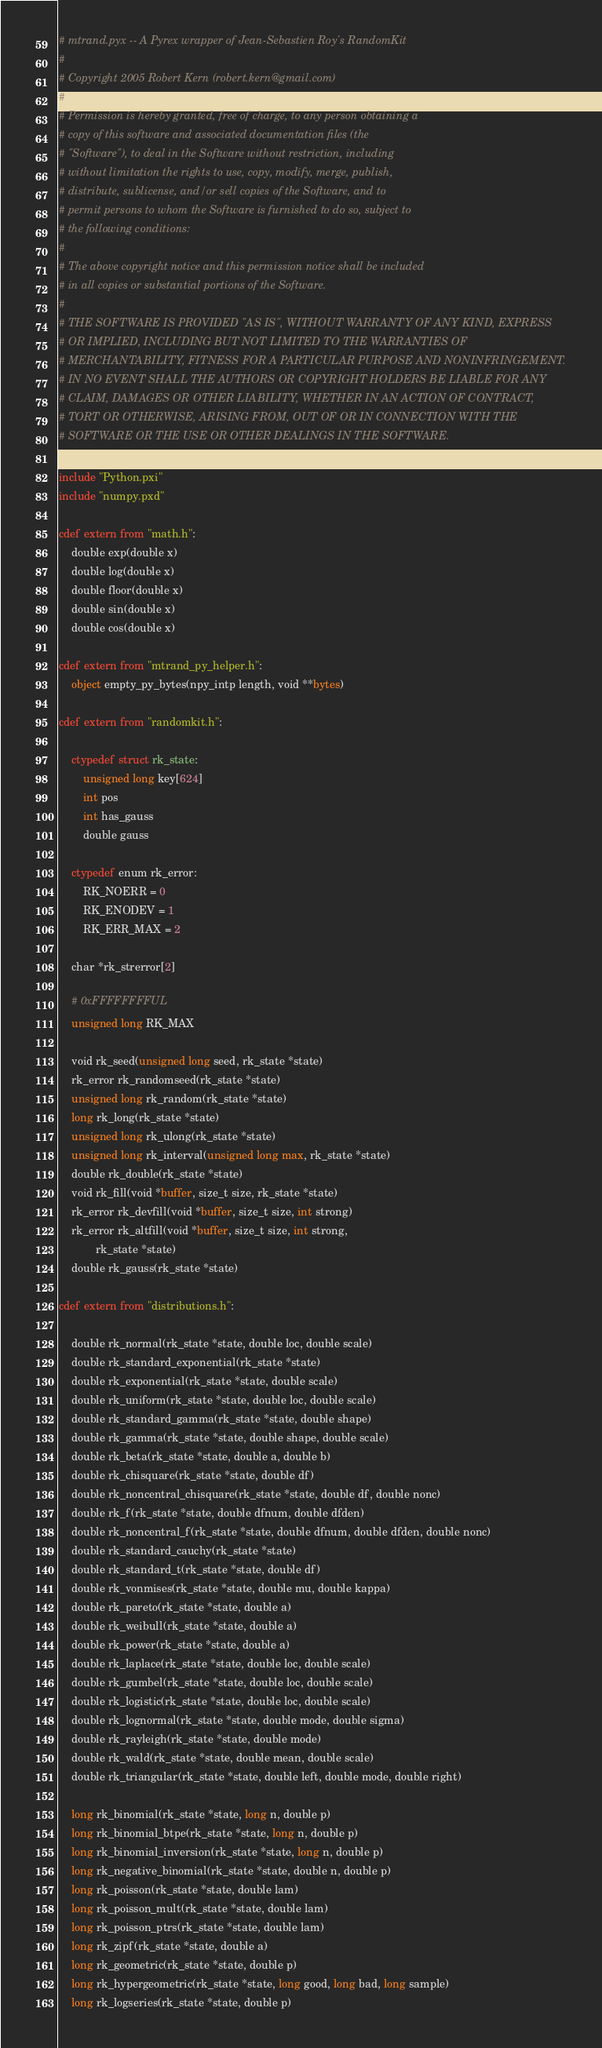Convert code to text. <code><loc_0><loc_0><loc_500><loc_500><_Cython_># mtrand.pyx -- A Pyrex wrapper of Jean-Sebastien Roy's RandomKit
#
# Copyright 2005 Robert Kern (robert.kern@gmail.com)
#
# Permission is hereby granted, free of charge, to any person obtaining a
# copy of this software and associated documentation files (the
# "Software"), to deal in the Software without restriction, including
# without limitation the rights to use, copy, modify, merge, publish,
# distribute, sublicense, and/or sell copies of the Software, and to
# permit persons to whom the Software is furnished to do so, subject to
# the following conditions:
#
# The above copyright notice and this permission notice shall be included
# in all copies or substantial portions of the Software.
#
# THE SOFTWARE IS PROVIDED "AS IS", WITHOUT WARRANTY OF ANY KIND, EXPRESS
# OR IMPLIED, INCLUDING BUT NOT LIMITED TO THE WARRANTIES OF
# MERCHANTABILITY, FITNESS FOR A PARTICULAR PURPOSE AND NONINFRINGEMENT.
# IN NO EVENT SHALL THE AUTHORS OR COPYRIGHT HOLDERS BE LIABLE FOR ANY
# CLAIM, DAMAGES OR OTHER LIABILITY, WHETHER IN AN ACTION OF CONTRACT,
# TORT OR OTHERWISE, ARISING FROM, OUT OF OR IN CONNECTION WITH THE
# SOFTWARE OR THE USE OR OTHER DEALINGS IN THE SOFTWARE.

include "Python.pxi"
include "numpy.pxd"

cdef extern from "math.h":
    double exp(double x)
    double log(double x)
    double floor(double x)
    double sin(double x)
    double cos(double x)

cdef extern from "mtrand_py_helper.h":
    object empty_py_bytes(npy_intp length, void **bytes)

cdef extern from "randomkit.h":

    ctypedef struct rk_state:
        unsigned long key[624]
        int pos
        int has_gauss
        double gauss

    ctypedef enum rk_error:
        RK_NOERR = 0
        RK_ENODEV = 1
        RK_ERR_MAX = 2

    char *rk_strerror[2]

    # 0xFFFFFFFFUL
    unsigned long RK_MAX

    void rk_seed(unsigned long seed, rk_state *state)
    rk_error rk_randomseed(rk_state *state)
    unsigned long rk_random(rk_state *state)
    long rk_long(rk_state *state)
    unsigned long rk_ulong(rk_state *state)
    unsigned long rk_interval(unsigned long max, rk_state *state)
    double rk_double(rk_state *state)
    void rk_fill(void *buffer, size_t size, rk_state *state)
    rk_error rk_devfill(void *buffer, size_t size, int strong)
    rk_error rk_altfill(void *buffer, size_t size, int strong,
            rk_state *state)
    double rk_gauss(rk_state *state)

cdef extern from "distributions.h":

    double rk_normal(rk_state *state, double loc, double scale)
    double rk_standard_exponential(rk_state *state)
    double rk_exponential(rk_state *state, double scale)
    double rk_uniform(rk_state *state, double loc, double scale)
    double rk_standard_gamma(rk_state *state, double shape)
    double rk_gamma(rk_state *state, double shape, double scale)
    double rk_beta(rk_state *state, double a, double b)
    double rk_chisquare(rk_state *state, double df)
    double rk_noncentral_chisquare(rk_state *state, double df, double nonc)
    double rk_f(rk_state *state, double dfnum, double dfden)
    double rk_noncentral_f(rk_state *state, double dfnum, double dfden, double nonc)
    double rk_standard_cauchy(rk_state *state)
    double rk_standard_t(rk_state *state, double df)
    double rk_vonmises(rk_state *state, double mu, double kappa)
    double rk_pareto(rk_state *state, double a)
    double rk_weibull(rk_state *state, double a)
    double rk_power(rk_state *state, double a)
    double rk_laplace(rk_state *state, double loc, double scale)
    double rk_gumbel(rk_state *state, double loc, double scale)
    double rk_logistic(rk_state *state, double loc, double scale)
    double rk_lognormal(rk_state *state, double mode, double sigma)
    double rk_rayleigh(rk_state *state, double mode)
    double rk_wald(rk_state *state, double mean, double scale)
    double rk_triangular(rk_state *state, double left, double mode, double right)

    long rk_binomial(rk_state *state, long n, double p)
    long rk_binomial_btpe(rk_state *state, long n, double p)
    long rk_binomial_inversion(rk_state *state, long n, double p)
    long rk_negative_binomial(rk_state *state, double n, double p)
    long rk_poisson(rk_state *state, double lam)
    long rk_poisson_mult(rk_state *state, double lam)
    long rk_poisson_ptrs(rk_state *state, double lam)
    long rk_zipf(rk_state *state, double a)
    long rk_geometric(rk_state *state, double p)
    long rk_hypergeometric(rk_state *state, long good, long bad, long sample)
    long rk_logseries(rk_state *state, double p)
</code> 